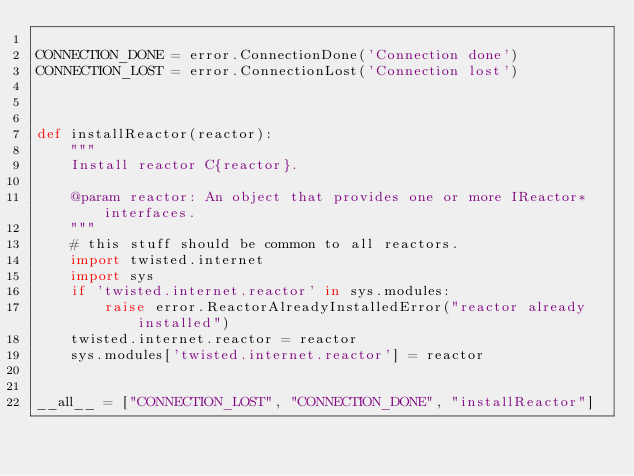Convert code to text. <code><loc_0><loc_0><loc_500><loc_500><_Python_>
CONNECTION_DONE = error.ConnectionDone('Connection done')
CONNECTION_LOST = error.ConnectionLost('Connection lost')



def installReactor(reactor):
    """
    Install reactor C{reactor}.

    @param reactor: An object that provides one or more IReactor* interfaces.
    """
    # this stuff should be common to all reactors.
    import twisted.internet
    import sys
    if 'twisted.internet.reactor' in sys.modules:
        raise error.ReactorAlreadyInstalledError("reactor already installed")
    twisted.internet.reactor = reactor
    sys.modules['twisted.internet.reactor'] = reactor


__all__ = ["CONNECTION_LOST", "CONNECTION_DONE", "installReactor"]
</code> 